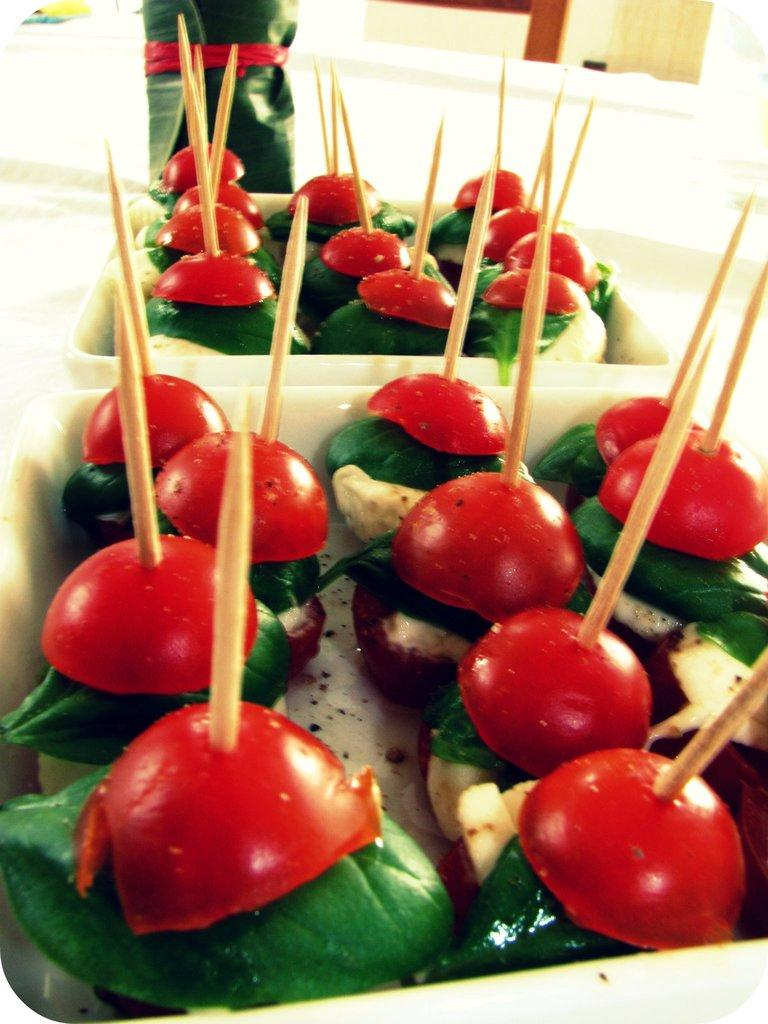What is the main subject of the image? The main subject of the image is food. How is the food arranged in the image? The food is in plates in the image. What are the toothpick sticks used for in the image? The toothpick sticks are present on the food, likely for holding or decorating the food. On what surface are the food and toothpick sticks placed? The food and toothpick sticks are placed on a surface in the image. What type of dog can be seen playing on the swing in the image? There is no dog or swing present in the image; it features food in plates with toothpick sticks. 